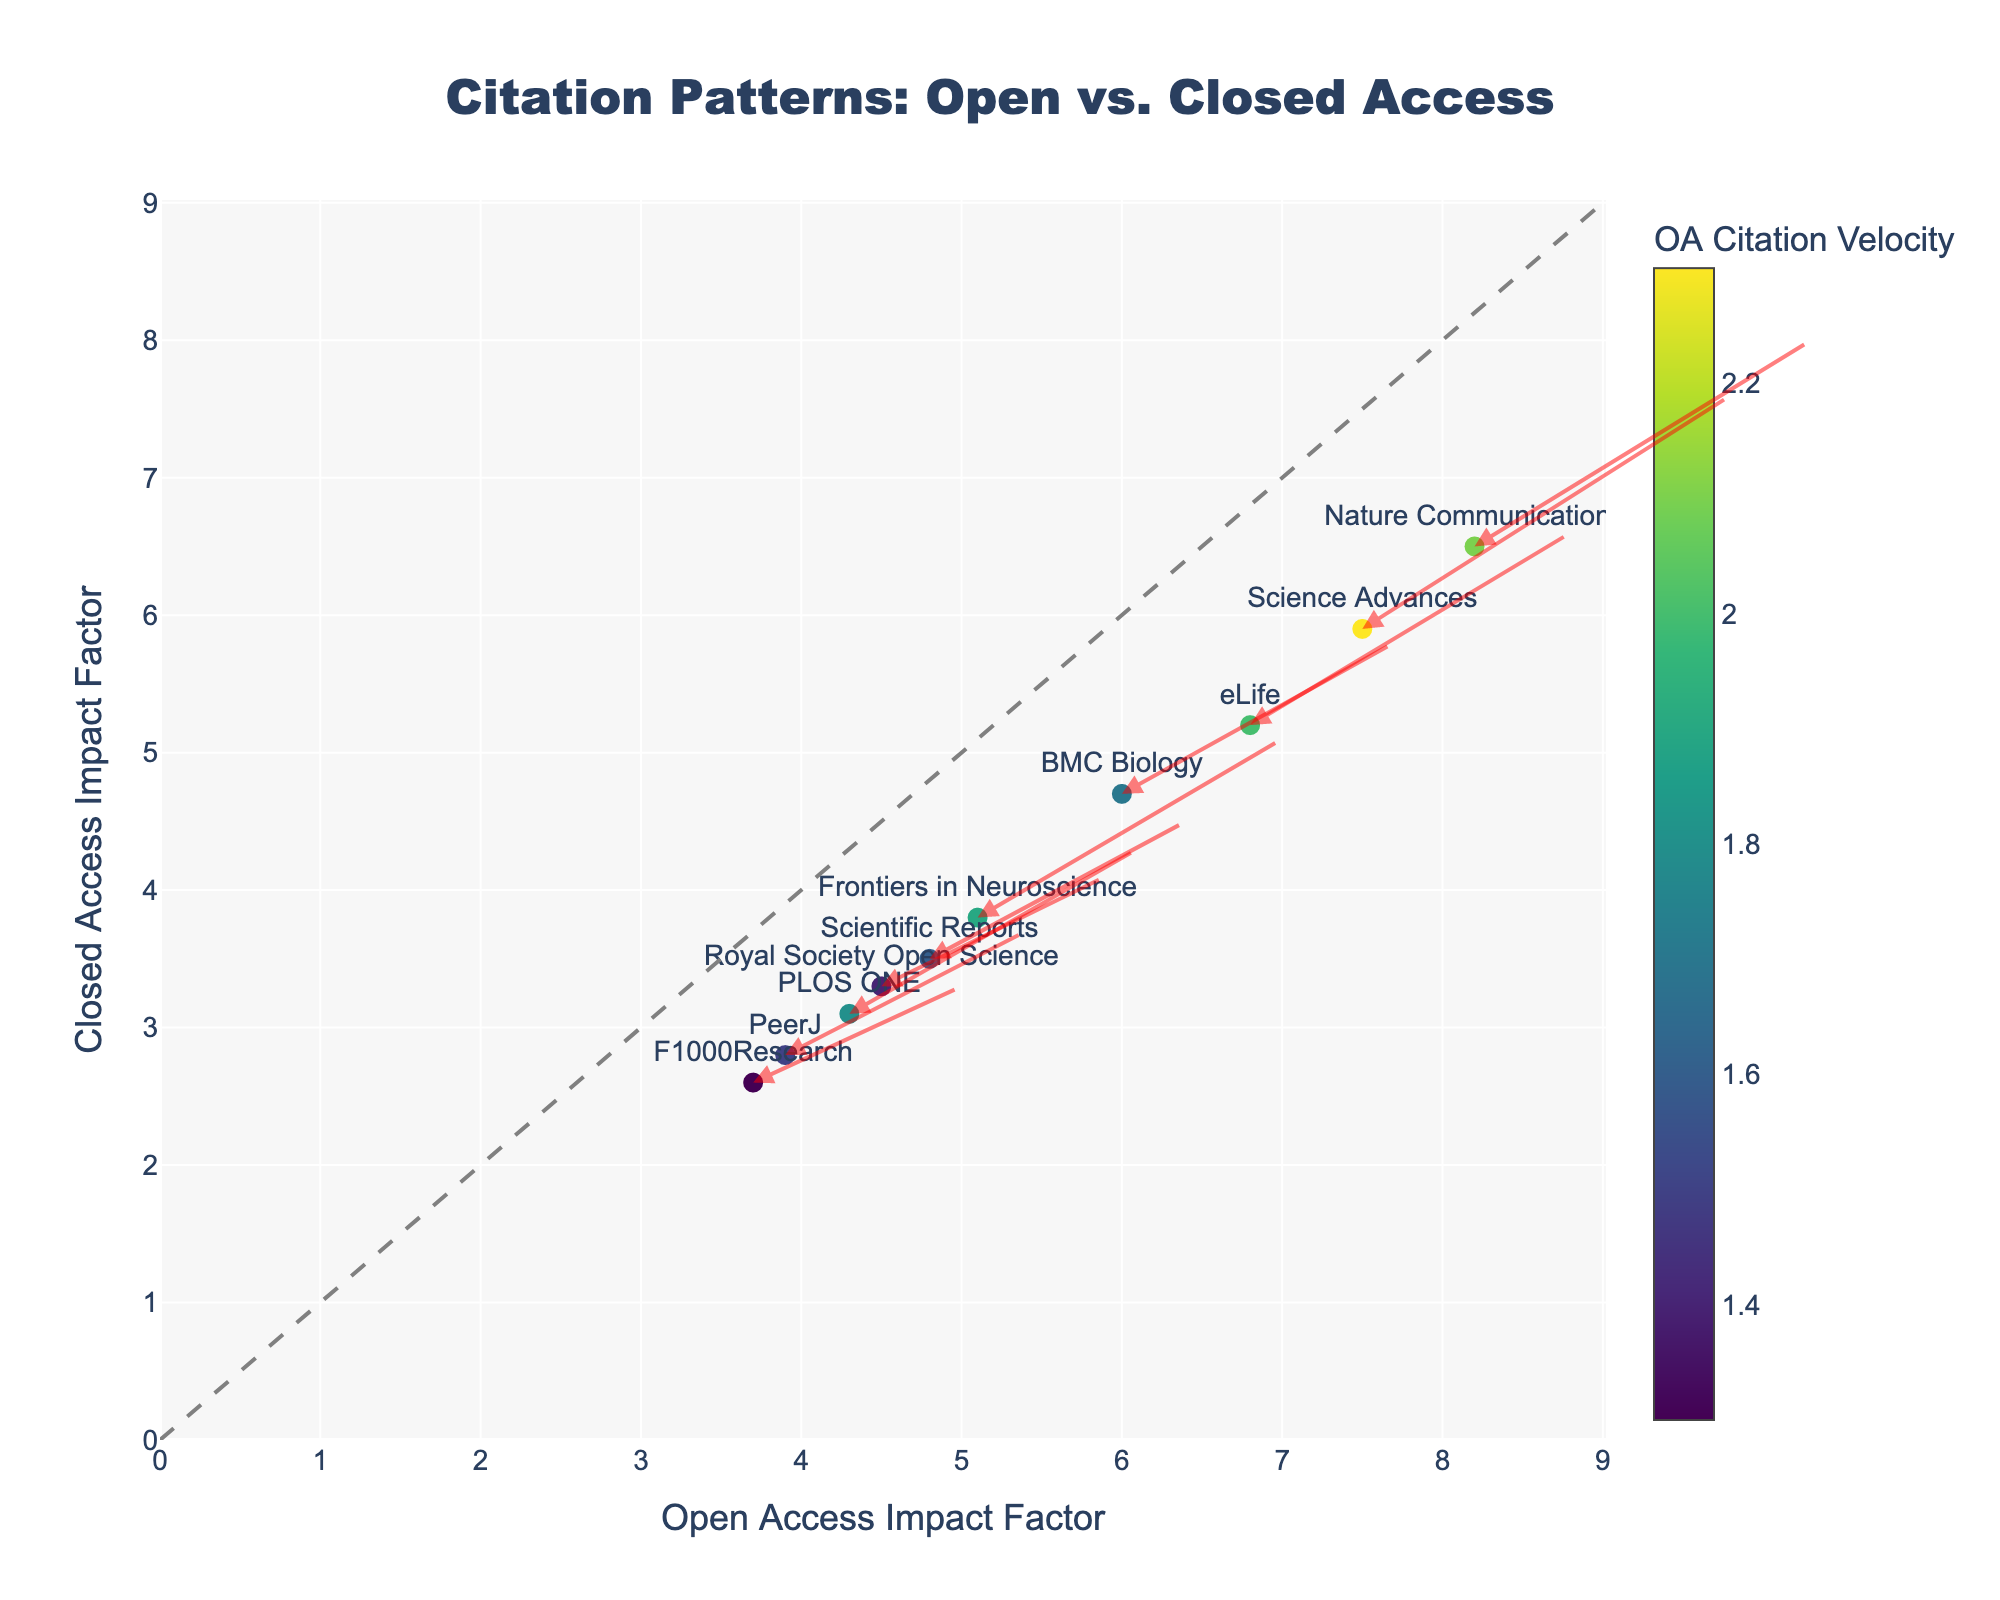What is the title of the plot? The title is displayed at the top center of the plot and reads "Citation Patterns: Open vs. Closed Access".
Answer: Citation Patterns: Open vs. Closed Access Which axis represents the Open Access Impact Factor? The x-axis represents the Open Access Impact Factor, as indicated by the label "Open Access Impact Factor".
Answer: x-axis How is the Closed Access Impact Factor represented in the plot? The Closed Access Impact Factor is represented on the y-axis, which is labeled "Closed Access Impact Factor".
Answer: y-axis How many journals are represented in the plot? By counting the number of unique data points with labels, we can see that there are 10 journals represented in the plot.
Answer: 10 Which journal has the highest Open Access Impact Factor? Nature Communications has the highest Open Access Impact Factor, with a value of 8.2, as seen at the right end of the x-axis.
Answer: Nature Communications How do the arrows in the plot help in interpreting citation trends? The arrows start from the Open Access Impact Factor and end at the sum of the Open Access Impact Factor and the respective citation velocity, indicating the magnitude and direction of citation trends.
Answer: Show citation trends Compare the Open Access and Closed Access Impact Factors for PLOS ONE. PLOS ONE has an Open Access Impact Factor of 4.3 and a Closed Access Impact Factor of 3.1, which shows that the Open Access Impact Factor is higher.
Answer: OA: 4.3, CA: 3.1 Which journal has the largest difference in citation velocities between Open Access and Closed Access? Science Advances has the largest difference in citation velocities (OA Citation Velocity: 2.3 and CA Citation Velocity: 1.7), giving a difference of 0.6.
Answer: Science Advances How does the color of the markers relate to the data? The color of the markers is determined by the OA Citation Velocity. Darker markers indicate higher OA Citation Velocities, as can be seen by the color scale.
Answer: OA Citation Velocity Which journal's Closed Access Impact Factor is closest to its Open Access Impact Factor? Nature Communications has Open and Closed Access Impact Factors of 8.2 and 6.5 respectively, which are the closest among the journals compared to others.
Answer: Nature Communications 